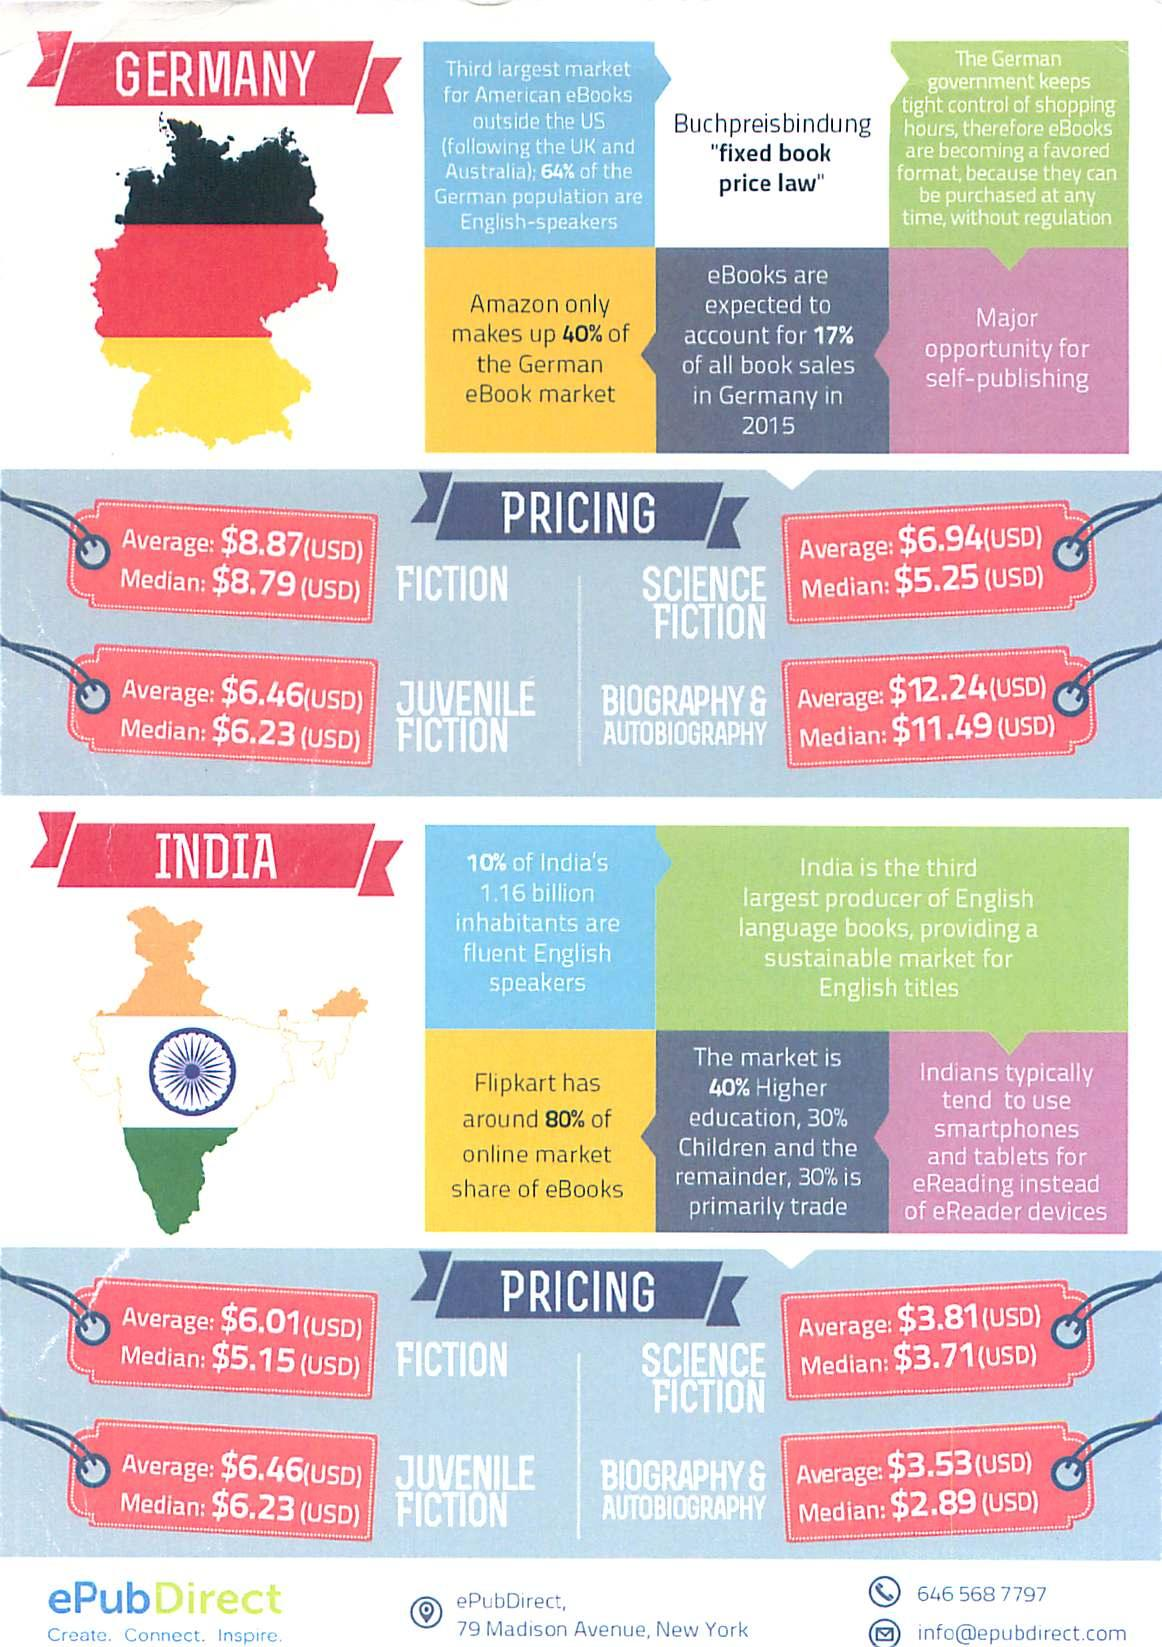Point out several critical features in this image. The second largest market for American eBooks outside the US is Australia. According to recent data, Flipcart holds an impressive 80% of the online market share in the eBooks industry. 